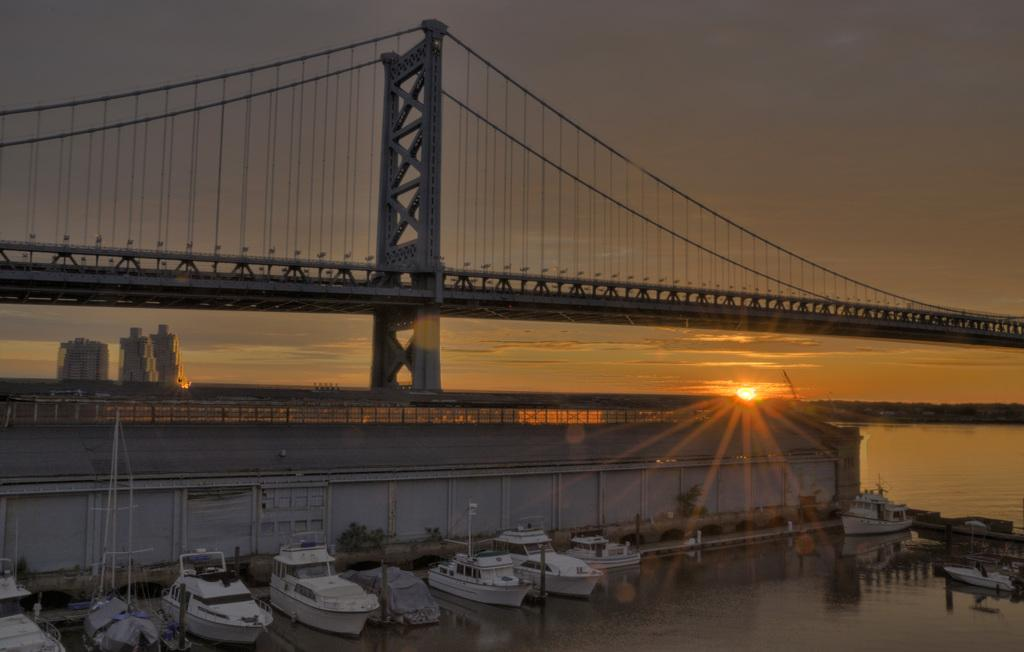What is the main structure in the middle of the image? There is a bridge in the middle of the image. What type of vehicles can be seen near the bridge? There are boats in white color on the down side of the bridge. What natural element is visible on the right side of the image? There is water visible on the right side of the image. What type of iron is used to make the boats in the image? There is no mention of iron being used to make the boats in the image. The boats are described as being white in color, but their construction material is not specified. 